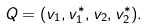Convert formula to latex. <formula><loc_0><loc_0><loc_500><loc_500>Q = ( v _ { 1 } , v _ { 1 } ^ { * } , v _ { 2 } , v _ { 2 } ^ { * } ) .</formula> 